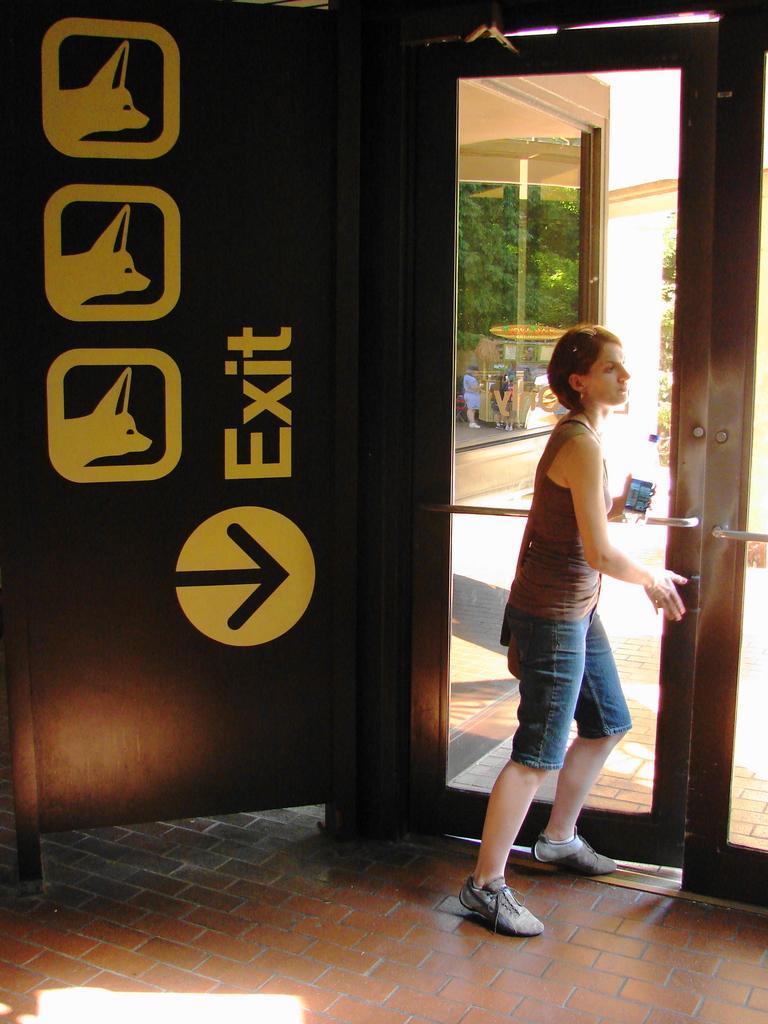In one or two sentences, can you explain what this image depicts? In this picture we can see a woman holding a phone in one hand and she is opening a door with another hand. We can see an arrow sign and EXIT is written on a brown board. Three animals are visible on this board. We can see few people and some trees in the background. 